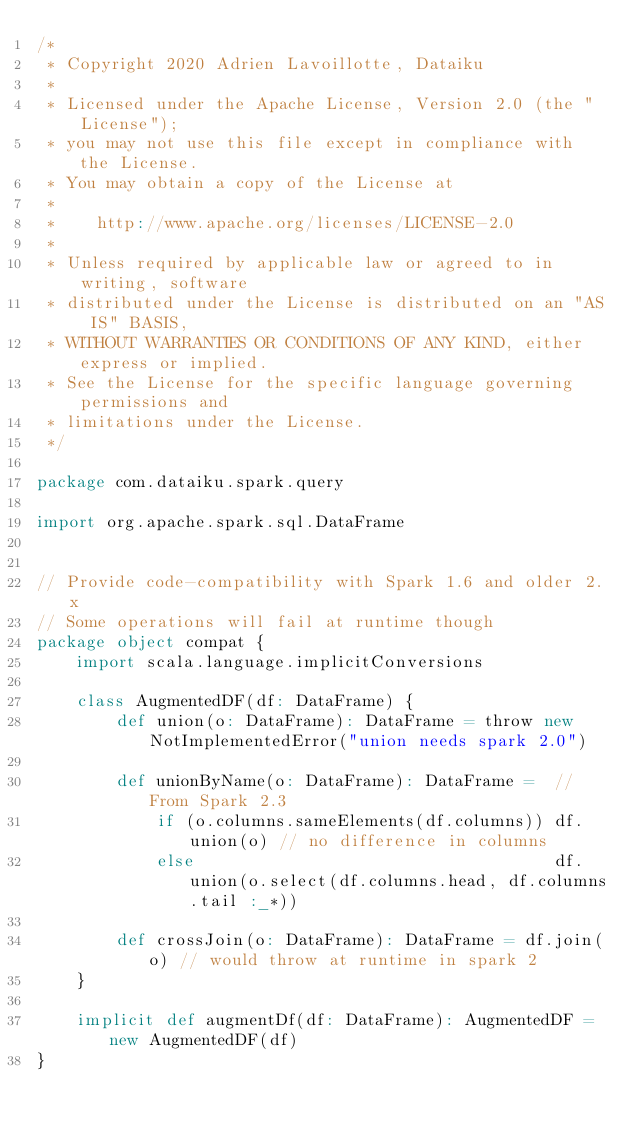<code> <loc_0><loc_0><loc_500><loc_500><_Scala_>/*
 * Copyright 2020 Adrien Lavoillotte, Dataiku
 *
 * Licensed under the Apache License, Version 2.0 (the "License");
 * you may not use this file except in compliance with the License.
 * You may obtain a copy of the License at
 *
 *    http://www.apache.org/licenses/LICENSE-2.0
 *
 * Unless required by applicable law or agreed to in writing, software
 * distributed under the License is distributed on an "AS IS" BASIS,
 * WITHOUT WARRANTIES OR CONDITIONS OF ANY KIND, either express or implied.
 * See the License for the specific language governing permissions and
 * limitations under the License.
 */

package com.dataiku.spark.query

import org.apache.spark.sql.DataFrame


// Provide code-compatibility with Spark 1.6 and older 2.x
// Some operations will fail at runtime though
package object compat {
    import scala.language.implicitConversions

    class AugmentedDF(df: DataFrame) {
        def union(o: DataFrame): DataFrame = throw new NotImplementedError("union needs spark 2.0")

        def unionByName(o: DataFrame): DataFrame =  // From Spark 2.3
            if (o.columns.sameElements(df.columns)) df.union(o) // no difference in columns
            else                                    df.union(o.select(df.columns.head, df.columns.tail :_*))

        def crossJoin(o: DataFrame): DataFrame = df.join(o) // would throw at runtime in spark 2
    }

    implicit def augmentDf(df: DataFrame): AugmentedDF = new AugmentedDF(df)
}
</code> 